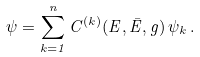Convert formula to latex. <formula><loc_0><loc_0><loc_500><loc_500>\psi = \sum _ { k = 1 } ^ { n } C ^ { ( k ) } ( E , \bar { E } , g ) \, \psi _ { k } \, .</formula> 